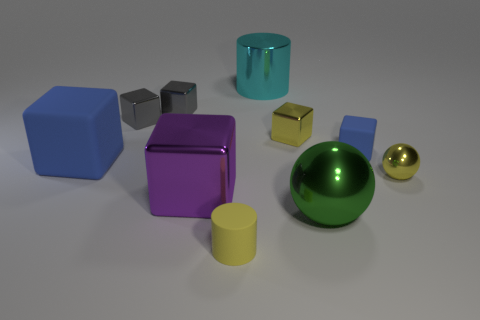Compare the sizes of the objects, which is the largest and smallest? In the image, the largest object appears to be the purple block, while the smallest objects are the tiny gray cubes. Do the shapes of these objects signify anything in particular? The objects represent basic geometric shapes like cubes, spheres, and cylinders. These often signify building blocks used in art and design to teach form, volume, and how light interacts with surfaces. 